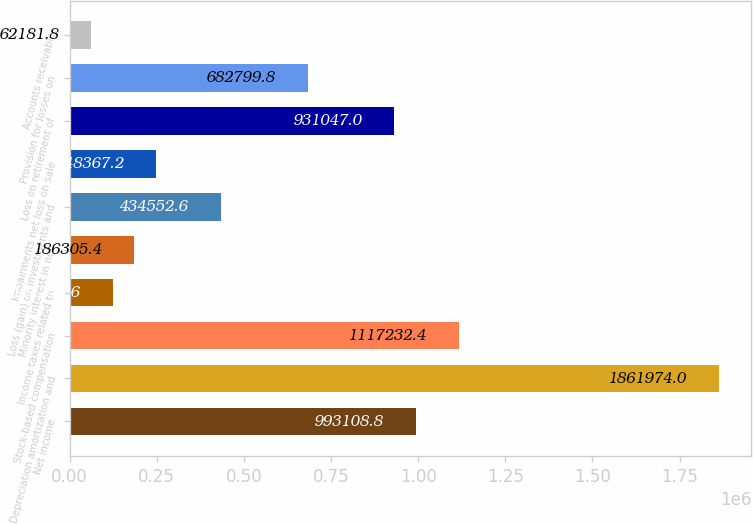Convert chart. <chart><loc_0><loc_0><loc_500><loc_500><bar_chart><fcel>Net income<fcel>Depreciation amortization and<fcel>Stock-based compensation<fcel>Income taxes related to<fcel>Minority interest in net<fcel>Loss (gain) on investments and<fcel>Impairments net loss on sale<fcel>Loss on retirement of<fcel>Provision for losses on<fcel>Accounts receivable<nl><fcel>993109<fcel>1.86197e+06<fcel>1.11723e+06<fcel>124244<fcel>186305<fcel>434553<fcel>248367<fcel>931047<fcel>682800<fcel>62181.8<nl></chart> 